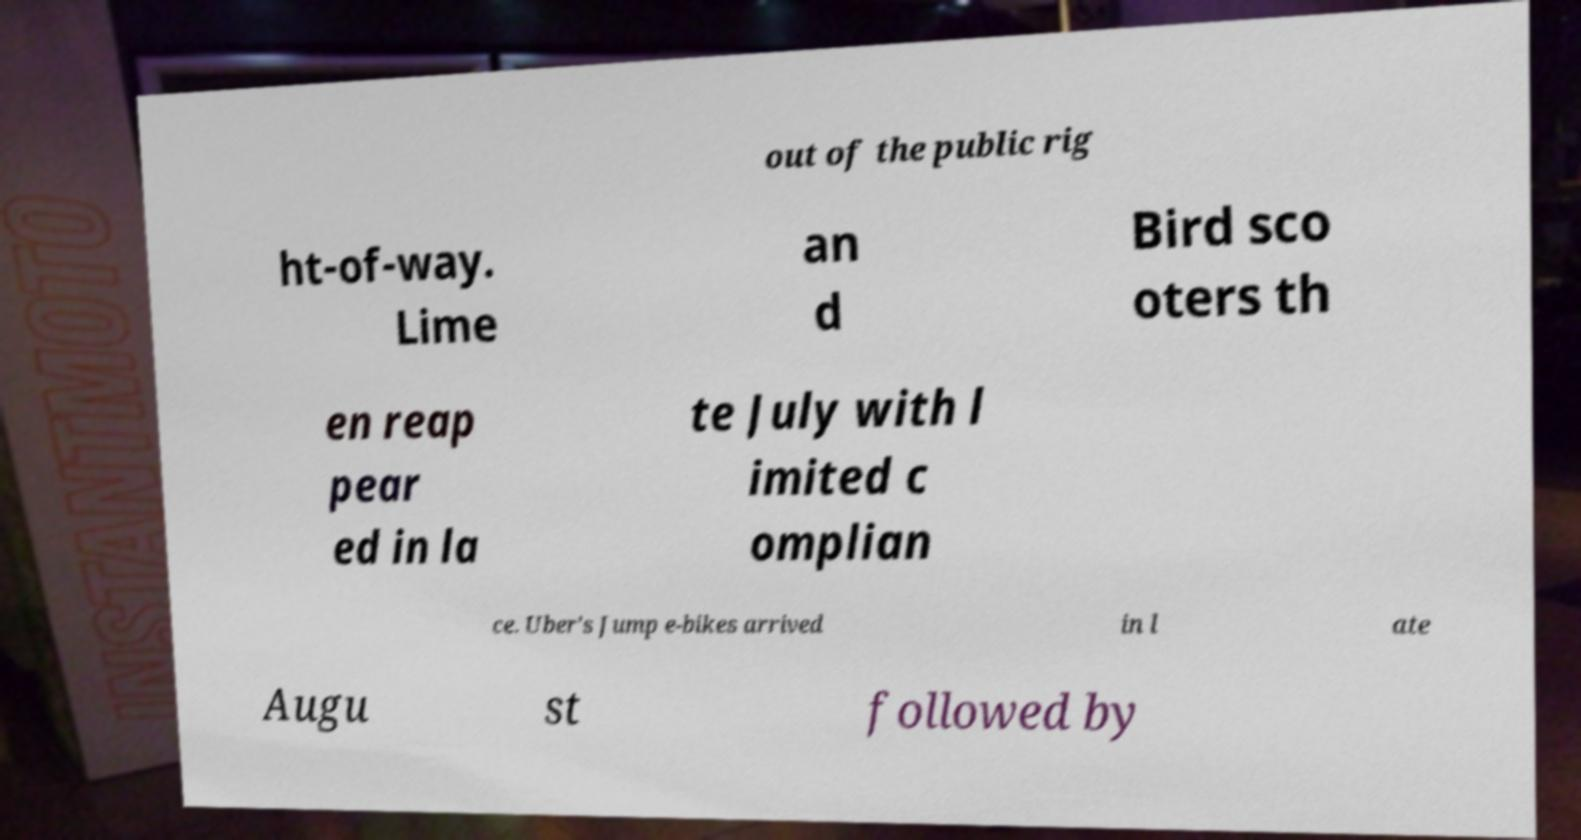What messages or text are displayed in this image? I need them in a readable, typed format. out of the public rig ht-of-way. Lime an d Bird sco oters th en reap pear ed in la te July with l imited c omplian ce. Uber's Jump e-bikes arrived in l ate Augu st followed by 